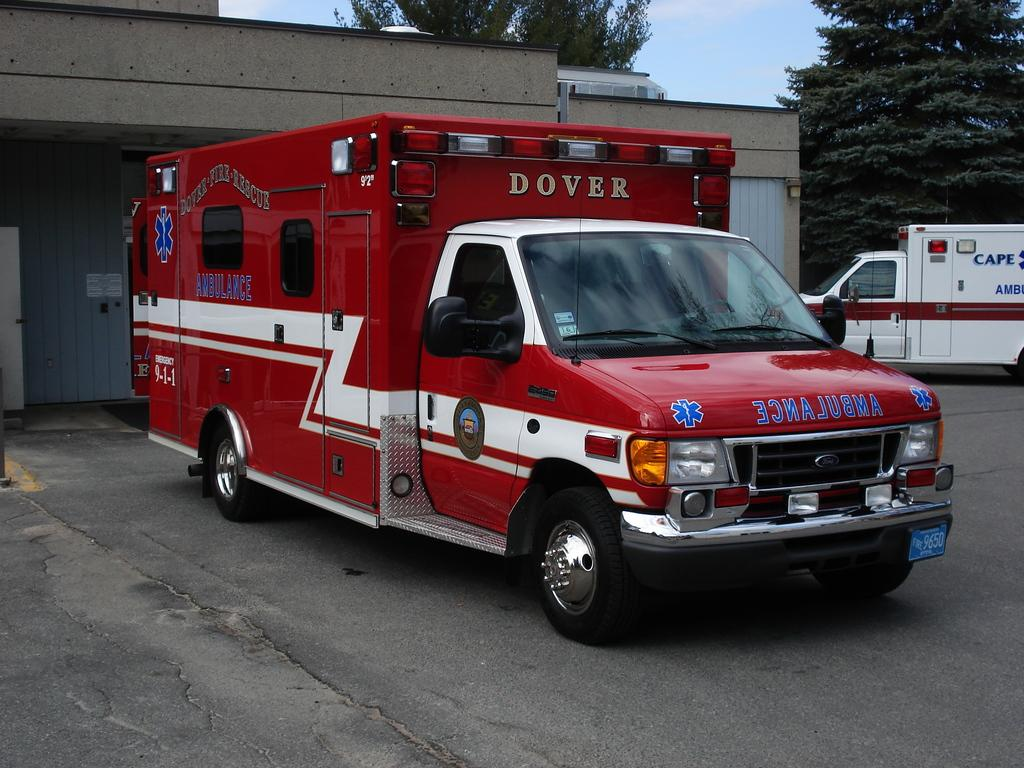What type of vehicles can be seen on the road in the image? There are motor vehicles on the road in the image. What structures are visible in the image? There are buildings visible in the image. What type of vegetation is present in the image? There are trees in the image. What is visible in the sky in the image? The sky is visible in the image, and clouds are present in the sky. Where is the ice located in the image? There is no ice present in the image. What type of church can be seen in the image? There is no church present in the image. 